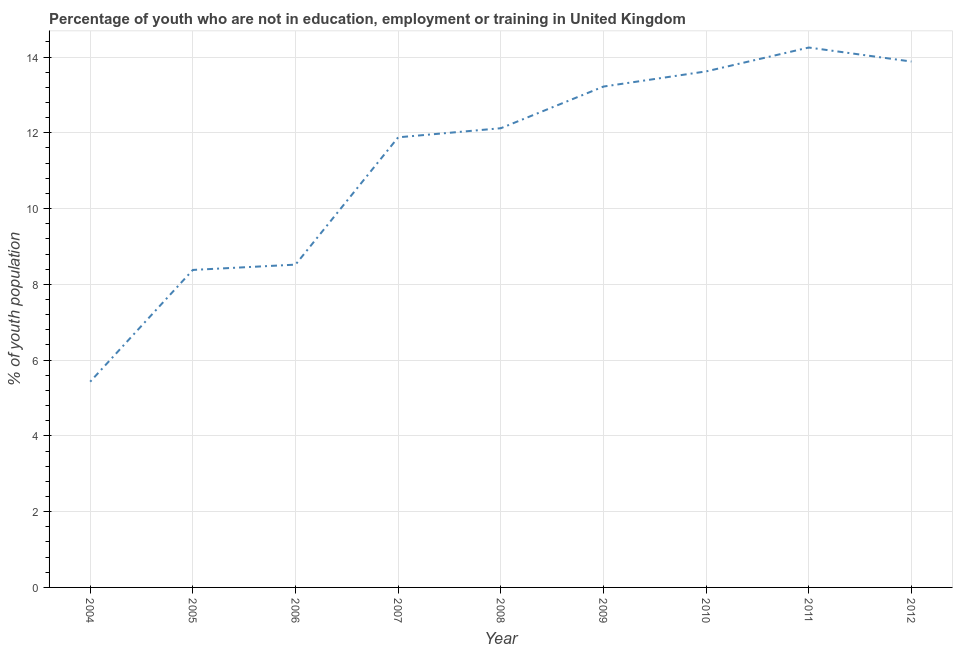What is the unemployed youth population in 2005?
Ensure brevity in your answer.  8.38. Across all years, what is the maximum unemployed youth population?
Keep it short and to the point. 14.25. Across all years, what is the minimum unemployed youth population?
Offer a terse response. 5.43. In which year was the unemployed youth population maximum?
Offer a terse response. 2011. What is the sum of the unemployed youth population?
Your answer should be compact. 101.3. What is the difference between the unemployed youth population in 2008 and 2011?
Offer a very short reply. -2.13. What is the average unemployed youth population per year?
Provide a succinct answer. 11.26. What is the median unemployed youth population?
Make the answer very short. 12.12. What is the ratio of the unemployed youth population in 2005 to that in 2009?
Offer a terse response. 0.63. Is the unemployed youth population in 2006 less than that in 2009?
Provide a succinct answer. Yes. What is the difference between the highest and the second highest unemployed youth population?
Make the answer very short. 0.37. What is the difference between the highest and the lowest unemployed youth population?
Offer a terse response. 8.82. How many lines are there?
Your answer should be very brief. 1. How many years are there in the graph?
Your answer should be compact. 9. What is the difference between two consecutive major ticks on the Y-axis?
Your response must be concise. 2. Are the values on the major ticks of Y-axis written in scientific E-notation?
Your answer should be compact. No. What is the title of the graph?
Your answer should be very brief. Percentage of youth who are not in education, employment or training in United Kingdom. What is the label or title of the Y-axis?
Your response must be concise. % of youth population. What is the % of youth population in 2004?
Provide a succinct answer. 5.43. What is the % of youth population in 2005?
Keep it short and to the point. 8.38. What is the % of youth population of 2006?
Provide a short and direct response. 8.52. What is the % of youth population of 2007?
Your response must be concise. 11.88. What is the % of youth population of 2008?
Provide a succinct answer. 12.12. What is the % of youth population in 2009?
Provide a short and direct response. 13.22. What is the % of youth population of 2010?
Offer a very short reply. 13.62. What is the % of youth population in 2011?
Offer a very short reply. 14.25. What is the % of youth population in 2012?
Provide a short and direct response. 13.88. What is the difference between the % of youth population in 2004 and 2005?
Provide a short and direct response. -2.95. What is the difference between the % of youth population in 2004 and 2006?
Make the answer very short. -3.09. What is the difference between the % of youth population in 2004 and 2007?
Make the answer very short. -6.45. What is the difference between the % of youth population in 2004 and 2008?
Provide a short and direct response. -6.69. What is the difference between the % of youth population in 2004 and 2009?
Make the answer very short. -7.79. What is the difference between the % of youth population in 2004 and 2010?
Your response must be concise. -8.19. What is the difference between the % of youth population in 2004 and 2011?
Give a very brief answer. -8.82. What is the difference between the % of youth population in 2004 and 2012?
Your answer should be very brief. -8.45. What is the difference between the % of youth population in 2005 and 2006?
Your answer should be compact. -0.14. What is the difference between the % of youth population in 2005 and 2007?
Your answer should be compact. -3.5. What is the difference between the % of youth population in 2005 and 2008?
Offer a terse response. -3.74. What is the difference between the % of youth population in 2005 and 2009?
Provide a short and direct response. -4.84. What is the difference between the % of youth population in 2005 and 2010?
Offer a very short reply. -5.24. What is the difference between the % of youth population in 2005 and 2011?
Offer a very short reply. -5.87. What is the difference between the % of youth population in 2006 and 2007?
Your answer should be compact. -3.36. What is the difference between the % of youth population in 2006 and 2008?
Offer a terse response. -3.6. What is the difference between the % of youth population in 2006 and 2011?
Keep it short and to the point. -5.73. What is the difference between the % of youth population in 2006 and 2012?
Your response must be concise. -5.36. What is the difference between the % of youth population in 2007 and 2008?
Give a very brief answer. -0.24. What is the difference between the % of youth population in 2007 and 2009?
Your answer should be very brief. -1.34. What is the difference between the % of youth population in 2007 and 2010?
Your answer should be very brief. -1.74. What is the difference between the % of youth population in 2007 and 2011?
Offer a terse response. -2.37. What is the difference between the % of youth population in 2007 and 2012?
Ensure brevity in your answer.  -2. What is the difference between the % of youth population in 2008 and 2011?
Provide a short and direct response. -2.13. What is the difference between the % of youth population in 2008 and 2012?
Offer a very short reply. -1.76. What is the difference between the % of youth population in 2009 and 2010?
Offer a terse response. -0.4. What is the difference between the % of youth population in 2009 and 2011?
Keep it short and to the point. -1.03. What is the difference between the % of youth population in 2009 and 2012?
Your answer should be compact. -0.66. What is the difference between the % of youth population in 2010 and 2011?
Give a very brief answer. -0.63. What is the difference between the % of youth population in 2010 and 2012?
Provide a succinct answer. -0.26. What is the difference between the % of youth population in 2011 and 2012?
Your response must be concise. 0.37. What is the ratio of the % of youth population in 2004 to that in 2005?
Offer a terse response. 0.65. What is the ratio of the % of youth population in 2004 to that in 2006?
Keep it short and to the point. 0.64. What is the ratio of the % of youth population in 2004 to that in 2007?
Offer a very short reply. 0.46. What is the ratio of the % of youth population in 2004 to that in 2008?
Your answer should be compact. 0.45. What is the ratio of the % of youth population in 2004 to that in 2009?
Give a very brief answer. 0.41. What is the ratio of the % of youth population in 2004 to that in 2010?
Your answer should be very brief. 0.4. What is the ratio of the % of youth population in 2004 to that in 2011?
Your answer should be very brief. 0.38. What is the ratio of the % of youth population in 2004 to that in 2012?
Ensure brevity in your answer.  0.39. What is the ratio of the % of youth population in 2005 to that in 2006?
Make the answer very short. 0.98. What is the ratio of the % of youth population in 2005 to that in 2007?
Your answer should be compact. 0.7. What is the ratio of the % of youth population in 2005 to that in 2008?
Your answer should be very brief. 0.69. What is the ratio of the % of youth population in 2005 to that in 2009?
Provide a succinct answer. 0.63. What is the ratio of the % of youth population in 2005 to that in 2010?
Your answer should be very brief. 0.61. What is the ratio of the % of youth population in 2005 to that in 2011?
Offer a terse response. 0.59. What is the ratio of the % of youth population in 2005 to that in 2012?
Provide a short and direct response. 0.6. What is the ratio of the % of youth population in 2006 to that in 2007?
Give a very brief answer. 0.72. What is the ratio of the % of youth population in 2006 to that in 2008?
Keep it short and to the point. 0.7. What is the ratio of the % of youth population in 2006 to that in 2009?
Provide a short and direct response. 0.64. What is the ratio of the % of youth population in 2006 to that in 2010?
Offer a terse response. 0.63. What is the ratio of the % of youth population in 2006 to that in 2011?
Your answer should be very brief. 0.6. What is the ratio of the % of youth population in 2006 to that in 2012?
Your answer should be compact. 0.61. What is the ratio of the % of youth population in 2007 to that in 2008?
Keep it short and to the point. 0.98. What is the ratio of the % of youth population in 2007 to that in 2009?
Keep it short and to the point. 0.9. What is the ratio of the % of youth population in 2007 to that in 2010?
Make the answer very short. 0.87. What is the ratio of the % of youth population in 2007 to that in 2011?
Your answer should be very brief. 0.83. What is the ratio of the % of youth population in 2007 to that in 2012?
Give a very brief answer. 0.86. What is the ratio of the % of youth population in 2008 to that in 2009?
Give a very brief answer. 0.92. What is the ratio of the % of youth population in 2008 to that in 2010?
Offer a terse response. 0.89. What is the ratio of the % of youth population in 2008 to that in 2011?
Offer a very short reply. 0.85. What is the ratio of the % of youth population in 2008 to that in 2012?
Keep it short and to the point. 0.87. What is the ratio of the % of youth population in 2009 to that in 2010?
Make the answer very short. 0.97. What is the ratio of the % of youth population in 2009 to that in 2011?
Provide a succinct answer. 0.93. What is the ratio of the % of youth population in 2009 to that in 2012?
Offer a terse response. 0.95. What is the ratio of the % of youth population in 2010 to that in 2011?
Ensure brevity in your answer.  0.96. What is the ratio of the % of youth population in 2010 to that in 2012?
Provide a short and direct response. 0.98. What is the ratio of the % of youth population in 2011 to that in 2012?
Give a very brief answer. 1.03. 